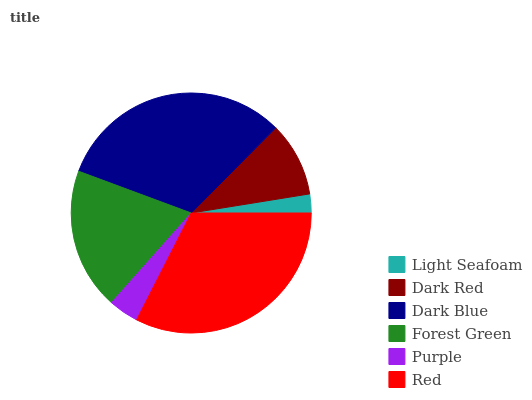Is Light Seafoam the minimum?
Answer yes or no. Yes. Is Red the maximum?
Answer yes or no. Yes. Is Dark Red the minimum?
Answer yes or no. No. Is Dark Red the maximum?
Answer yes or no. No. Is Dark Red greater than Light Seafoam?
Answer yes or no. Yes. Is Light Seafoam less than Dark Red?
Answer yes or no. Yes. Is Light Seafoam greater than Dark Red?
Answer yes or no. No. Is Dark Red less than Light Seafoam?
Answer yes or no. No. Is Forest Green the high median?
Answer yes or no. Yes. Is Dark Red the low median?
Answer yes or no. Yes. Is Purple the high median?
Answer yes or no. No. Is Purple the low median?
Answer yes or no. No. 